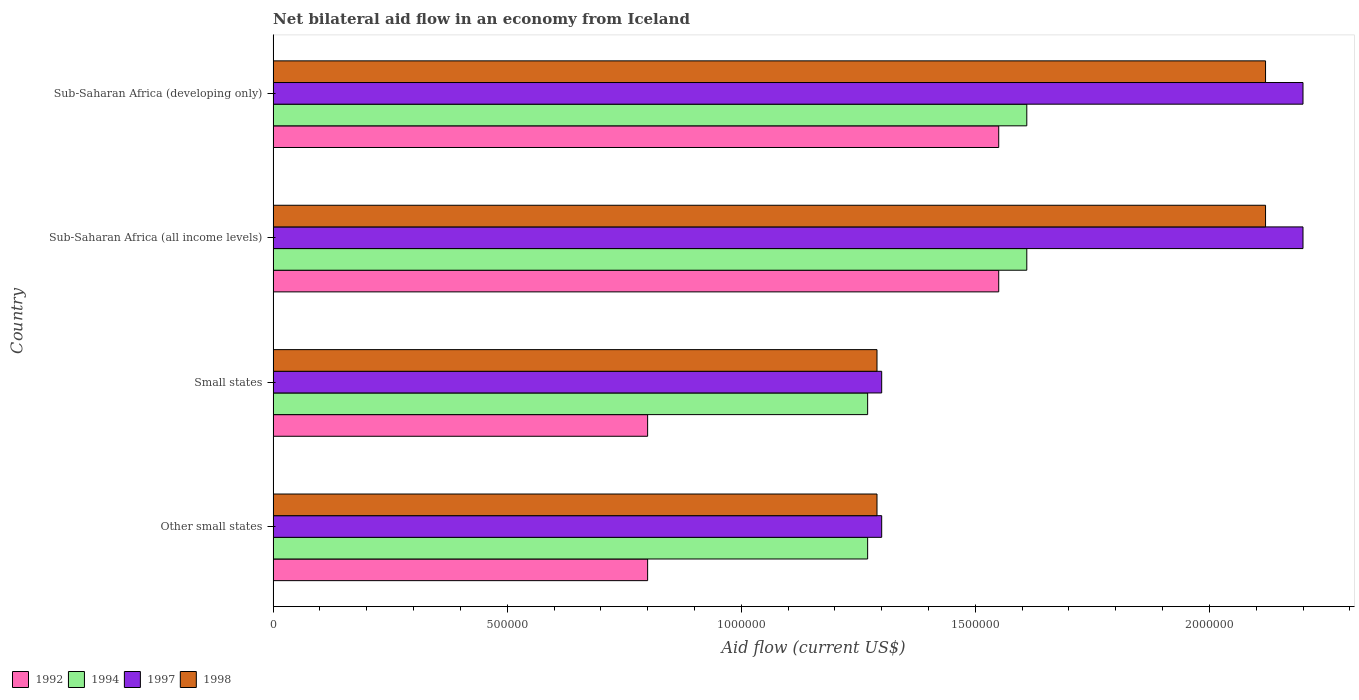How many different coloured bars are there?
Ensure brevity in your answer.  4. Are the number of bars per tick equal to the number of legend labels?
Offer a terse response. Yes. How many bars are there on the 4th tick from the bottom?
Keep it short and to the point. 4. What is the label of the 4th group of bars from the top?
Your response must be concise. Other small states. In how many cases, is the number of bars for a given country not equal to the number of legend labels?
Your answer should be compact. 0. What is the net bilateral aid flow in 1992 in Small states?
Your answer should be very brief. 8.00e+05. Across all countries, what is the maximum net bilateral aid flow in 1994?
Offer a very short reply. 1.61e+06. Across all countries, what is the minimum net bilateral aid flow in 1994?
Your answer should be compact. 1.27e+06. In which country was the net bilateral aid flow in 1998 maximum?
Your answer should be very brief. Sub-Saharan Africa (all income levels). In which country was the net bilateral aid flow in 1997 minimum?
Provide a succinct answer. Other small states. What is the total net bilateral aid flow in 1997 in the graph?
Make the answer very short. 7.00e+06. What is the difference between the net bilateral aid flow in 1992 in Small states and that in Sub-Saharan Africa (developing only)?
Give a very brief answer. -7.50e+05. What is the difference between the net bilateral aid flow in 1994 in Sub-Saharan Africa (developing only) and the net bilateral aid flow in 1992 in Other small states?
Provide a short and direct response. 8.10e+05. What is the average net bilateral aid flow in 1994 per country?
Your answer should be very brief. 1.44e+06. What is the difference between the net bilateral aid flow in 1994 and net bilateral aid flow in 1998 in Sub-Saharan Africa (developing only)?
Provide a succinct answer. -5.10e+05. What is the ratio of the net bilateral aid flow in 1998 in Other small states to that in Sub-Saharan Africa (all income levels)?
Offer a very short reply. 0.61. Is the difference between the net bilateral aid flow in 1994 in Sub-Saharan Africa (all income levels) and Sub-Saharan Africa (developing only) greater than the difference between the net bilateral aid flow in 1998 in Sub-Saharan Africa (all income levels) and Sub-Saharan Africa (developing only)?
Keep it short and to the point. No. In how many countries, is the net bilateral aid flow in 1997 greater than the average net bilateral aid flow in 1997 taken over all countries?
Your answer should be very brief. 2. Is it the case that in every country, the sum of the net bilateral aid flow in 1994 and net bilateral aid flow in 1997 is greater than the sum of net bilateral aid flow in 1992 and net bilateral aid flow in 1998?
Ensure brevity in your answer.  No. What does the 4th bar from the bottom in Sub-Saharan Africa (developing only) represents?
Your response must be concise. 1998. Is it the case that in every country, the sum of the net bilateral aid flow in 1997 and net bilateral aid flow in 1998 is greater than the net bilateral aid flow in 1992?
Your answer should be very brief. Yes. Are all the bars in the graph horizontal?
Your response must be concise. Yes. How many countries are there in the graph?
Offer a terse response. 4. Where does the legend appear in the graph?
Your answer should be very brief. Bottom left. How many legend labels are there?
Your response must be concise. 4. What is the title of the graph?
Your response must be concise. Net bilateral aid flow in an economy from Iceland. What is the label or title of the X-axis?
Your answer should be compact. Aid flow (current US$). What is the label or title of the Y-axis?
Make the answer very short. Country. What is the Aid flow (current US$) in 1994 in Other small states?
Ensure brevity in your answer.  1.27e+06. What is the Aid flow (current US$) in 1997 in Other small states?
Your answer should be compact. 1.30e+06. What is the Aid flow (current US$) in 1998 in Other small states?
Make the answer very short. 1.29e+06. What is the Aid flow (current US$) in 1992 in Small states?
Your answer should be compact. 8.00e+05. What is the Aid flow (current US$) in 1994 in Small states?
Make the answer very short. 1.27e+06. What is the Aid flow (current US$) in 1997 in Small states?
Make the answer very short. 1.30e+06. What is the Aid flow (current US$) of 1998 in Small states?
Your answer should be compact. 1.29e+06. What is the Aid flow (current US$) in 1992 in Sub-Saharan Africa (all income levels)?
Ensure brevity in your answer.  1.55e+06. What is the Aid flow (current US$) of 1994 in Sub-Saharan Africa (all income levels)?
Your answer should be compact. 1.61e+06. What is the Aid flow (current US$) of 1997 in Sub-Saharan Africa (all income levels)?
Provide a short and direct response. 2.20e+06. What is the Aid flow (current US$) of 1998 in Sub-Saharan Africa (all income levels)?
Make the answer very short. 2.12e+06. What is the Aid flow (current US$) of 1992 in Sub-Saharan Africa (developing only)?
Make the answer very short. 1.55e+06. What is the Aid flow (current US$) of 1994 in Sub-Saharan Africa (developing only)?
Your response must be concise. 1.61e+06. What is the Aid flow (current US$) in 1997 in Sub-Saharan Africa (developing only)?
Your response must be concise. 2.20e+06. What is the Aid flow (current US$) in 1998 in Sub-Saharan Africa (developing only)?
Keep it short and to the point. 2.12e+06. Across all countries, what is the maximum Aid flow (current US$) of 1992?
Give a very brief answer. 1.55e+06. Across all countries, what is the maximum Aid flow (current US$) in 1994?
Provide a succinct answer. 1.61e+06. Across all countries, what is the maximum Aid flow (current US$) of 1997?
Provide a succinct answer. 2.20e+06. Across all countries, what is the maximum Aid flow (current US$) of 1998?
Provide a short and direct response. 2.12e+06. Across all countries, what is the minimum Aid flow (current US$) in 1994?
Your answer should be compact. 1.27e+06. Across all countries, what is the minimum Aid flow (current US$) in 1997?
Your answer should be compact. 1.30e+06. Across all countries, what is the minimum Aid flow (current US$) in 1998?
Provide a succinct answer. 1.29e+06. What is the total Aid flow (current US$) of 1992 in the graph?
Your answer should be compact. 4.70e+06. What is the total Aid flow (current US$) in 1994 in the graph?
Ensure brevity in your answer.  5.76e+06. What is the total Aid flow (current US$) in 1997 in the graph?
Offer a terse response. 7.00e+06. What is the total Aid flow (current US$) of 1998 in the graph?
Offer a terse response. 6.82e+06. What is the difference between the Aid flow (current US$) of 1992 in Other small states and that in Small states?
Offer a very short reply. 0. What is the difference between the Aid flow (current US$) of 1994 in Other small states and that in Small states?
Offer a terse response. 0. What is the difference between the Aid flow (current US$) of 1997 in Other small states and that in Small states?
Your response must be concise. 0. What is the difference between the Aid flow (current US$) of 1998 in Other small states and that in Small states?
Keep it short and to the point. 0. What is the difference between the Aid flow (current US$) of 1992 in Other small states and that in Sub-Saharan Africa (all income levels)?
Your response must be concise. -7.50e+05. What is the difference between the Aid flow (current US$) of 1997 in Other small states and that in Sub-Saharan Africa (all income levels)?
Offer a terse response. -9.00e+05. What is the difference between the Aid flow (current US$) in 1998 in Other small states and that in Sub-Saharan Africa (all income levels)?
Offer a terse response. -8.30e+05. What is the difference between the Aid flow (current US$) of 1992 in Other small states and that in Sub-Saharan Africa (developing only)?
Your answer should be compact. -7.50e+05. What is the difference between the Aid flow (current US$) of 1994 in Other small states and that in Sub-Saharan Africa (developing only)?
Provide a short and direct response. -3.40e+05. What is the difference between the Aid flow (current US$) of 1997 in Other small states and that in Sub-Saharan Africa (developing only)?
Give a very brief answer. -9.00e+05. What is the difference between the Aid flow (current US$) of 1998 in Other small states and that in Sub-Saharan Africa (developing only)?
Keep it short and to the point. -8.30e+05. What is the difference between the Aid flow (current US$) in 1992 in Small states and that in Sub-Saharan Africa (all income levels)?
Provide a succinct answer. -7.50e+05. What is the difference between the Aid flow (current US$) of 1997 in Small states and that in Sub-Saharan Africa (all income levels)?
Your response must be concise. -9.00e+05. What is the difference between the Aid flow (current US$) of 1998 in Small states and that in Sub-Saharan Africa (all income levels)?
Offer a terse response. -8.30e+05. What is the difference between the Aid flow (current US$) in 1992 in Small states and that in Sub-Saharan Africa (developing only)?
Your answer should be very brief. -7.50e+05. What is the difference between the Aid flow (current US$) of 1994 in Small states and that in Sub-Saharan Africa (developing only)?
Keep it short and to the point. -3.40e+05. What is the difference between the Aid flow (current US$) of 1997 in Small states and that in Sub-Saharan Africa (developing only)?
Keep it short and to the point. -9.00e+05. What is the difference between the Aid flow (current US$) in 1998 in Small states and that in Sub-Saharan Africa (developing only)?
Offer a terse response. -8.30e+05. What is the difference between the Aid flow (current US$) of 1992 in Other small states and the Aid flow (current US$) of 1994 in Small states?
Give a very brief answer. -4.70e+05. What is the difference between the Aid flow (current US$) of 1992 in Other small states and the Aid flow (current US$) of 1997 in Small states?
Provide a short and direct response. -5.00e+05. What is the difference between the Aid flow (current US$) in 1992 in Other small states and the Aid flow (current US$) in 1998 in Small states?
Your answer should be compact. -4.90e+05. What is the difference between the Aid flow (current US$) in 1994 in Other small states and the Aid flow (current US$) in 1998 in Small states?
Give a very brief answer. -2.00e+04. What is the difference between the Aid flow (current US$) in 1992 in Other small states and the Aid flow (current US$) in 1994 in Sub-Saharan Africa (all income levels)?
Keep it short and to the point. -8.10e+05. What is the difference between the Aid flow (current US$) in 1992 in Other small states and the Aid flow (current US$) in 1997 in Sub-Saharan Africa (all income levels)?
Provide a short and direct response. -1.40e+06. What is the difference between the Aid flow (current US$) of 1992 in Other small states and the Aid flow (current US$) of 1998 in Sub-Saharan Africa (all income levels)?
Your answer should be very brief. -1.32e+06. What is the difference between the Aid flow (current US$) of 1994 in Other small states and the Aid flow (current US$) of 1997 in Sub-Saharan Africa (all income levels)?
Your answer should be very brief. -9.30e+05. What is the difference between the Aid flow (current US$) in 1994 in Other small states and the Aid flow (current US$) in 1998 in Sub-Saharan Africa (all income levels)?
Your answer should be compact. -8.50e+05. What is the difference between the Aid flow (current US$) in 1997 in Other small states and the Aid flow (current US$) in 1998 in Sub-Saharan Africa (all income levels)?
Offer a very short reply. -8.20e+05. What is the difference between the Aid flow (current US$) in 1992 in Other small states and the Aid flow (current US$) in 1994 in Sub-Saharan Africa (developing only)?
Provide a short and direct response. -8.10e+05. What is the difference between the Aid flow (current US$) in 1992 in Other small states and the Aid flow (current US$) in 1997 in Sub-Saharan Africa (developing only)?
Your answer should be compact. -1.40e+06. What is the difference between the Aid flow (current US$) in 1992 in Other small states and the Aid flow (current US$) in 1998 in Sub-Saharan Africa (developing only)?
Keep it short and to the point. -1.32e+06. What is the difference between the Aid flow (current US$) of 1994 in Other small states and the Aid flow (current US$) of 1997 in Sub-Saharan Africa (developing only)?
Ensure brevity in your answer.  -9.30e+05. What is the difference between the Aid flow (current US$) in 1994 in Other small states and the Aid flow (current US$) in 1998 in Sub-Saharan Africa (developing only)?
Provide a succinct answer. -8.50e+05. What is the difference between the Aid flow (current US$) in 1997 in Other small states and the Aid flow (current US$) in 1998 in Sub-Saharan Africa (developing only)?
Ensure brevity in your answer.  -8.20e+05. What is the difference between the Aid flow (current US$) of 1992 in Small states and the Aid flow (current US$) of 1994 in Sub-Saharan Africa (all income levels)?
Give a very brief answer. -8.10e+05. What is the difference between the Aid flow (current US$) in 1992 in Small states and the Aid flow (current US$) in 1997 in Sub-Saharan Africa (all income levels)?
Your response must be concise. -1.40e+06. What is the difference between the Aid flow (current US$) of 1992 in Small states and the Aid flow (current US$) of 1998 in Sub-Saharan Africa (all income levels)?
Provide a short and direct response. -1.32e+06. What is the difference between the Aid flow (current US$) in 1994 in Small states and the Aid flow (current US$) in 1997 in Sub-Saharan Africa (all income levels)?
Ensure brevity in your answer.  -9.30e+05. What is the difference between the Aid flow (current US$) of 1994 in Small states and the Aid flow (current US$) of 1998 in Sub-Saharan Africa (all income levels)?
Your response must be concise. -8.50e+05. What is the difference between the Aid flow (current US$) in 1997 in Small states and the Aid flow (current US$) in 1998 in Sub-Saharan Africa (all income levels)?
Give a very brief answer. -8.20e+05. What is the difference between the Aid flow (current US$) in 1992 in Small states and the Aid flow (current US$) in 1994 in Sub-Saharan Africa (developing only)?
Your response must be concise. -8.10e+05. What is the difference between the Aid flow (current US$) of 1992 in Small states and the Aid flow (current US$) of 1997 in Sub-Saharan Africa (developing only)?
Provide a short and direct response. -1.40e+06. What is the difference between the Aid flow (current US$) in 1992 in Small states and the Aid flow (current US$) in 1998 in Sub-Saharan Africa (developing only)?
Offer a terse response. -1.32e+06. What is the difference between the Aid flow (current US$) of 1994 in Small states and the Aid flow (current US$) of 1997 in Sub-Saharan Africa (developing only)?
Give a very brief answer. -9.30e+05. What is the difference between the Aid flow (current US$) of 1994 in Small states and the Aid flow (current US$) of 1998 in Sub-Saharan Africa (developing only)?
Make the answer very short. -8.50e+05. What is the difference between the Aid flow (current US$) of 1997 in Small states and the Aid flow (current US$) of 1998 in Sub-Saharan Africa (developing only)?
Your response must be concise. -8.20e+05. What is the difference between the Aid flow (current US$) of 1992 in Sub-Saharan Africa (all income levels) and the Aid flow (current US$) of 1994 in Sub-Saharan Africa (developing only)?
Provide a succinct answer. -6.00e+04. What is the difference between the Aid flow (current US$) in 1992 in Sub-Saharan Africa (all income levels) and the Aid flow (current US$) in 1997 in Sub-Saharan Africa (developing only)?
Give a very brief answer. -6.50e+05. What is the difference between the Aid flow (current US$) of 1992 in Sub-Saharan Africa (all income levels) and the Aid flow (current US$) of 1998 in Sub-Saharan Africa (developing only)?
Provide a succinct answer. -5.70e+05. What is the difference between the Aid flow (current US$) of 1994 in Sub-Saharan Africa (all income levels) and the Aid flow (current US$) of 1997 in Sub-Saharan Africa (developing only)?
Your answer should be very brief. -5.90e+05. What is the difference between the Aid flow (current US$) in 1994 in Sub-Saharan Africa (all income levels) and the Aid flow (current US$) in 1998 in Sub-Saharan Africa (developing only)?
Keep it short and to the point. -5.10e+05. What is the average Aid flow (current US$) of 1992 per country?
Your response must be concise. 1.18e+06. What is the average Aid flow (current US$) in 1994 per country?
Offer a very short reply. 1.44e+06. What is the average Aid flow (current US$) in 1997 per country?
Offer a very short reply. 1.75e+06. What is the average Aid flow (current US$) of 1998 per country?
Offer a very short reply. 1.70e+06. What is the difference between the Aid flow (current US$) in 1992 and Aid flow (current US$) in 1994 in Other small states?
Your answer should be compact. -4.70e+05. What is the difference between the Aid flow (current US$) in 1992 and Aid flow (current US$) in 1997 in Other small states?
Your response must be concise. -5.00e+05. What is the difference between the Aid flow (current US$) of 1992 and Aid flow (current US$) of 1998 in Other small states?
Your answer should be compact. -4.90e+05. What is the difference between the Aid flow (current US$) of 1994 and Aid flow (current US$) of 1997 in Other small states?
Make the answer very short. -3.00e+04. What is the difference between the Aid flow (current US$) of 1992 and Aid flow (current US$) of 1994 in Small states?
Your answer should be very brief. -4.70e+05. What is the difference between the Aid flow (current US$) in 1992 and Aid flow (current US$) in 1997 in Small states?
Offer a very short reply. -5.00e+05. What is the difference between the Aid flow (current US$) of 1992 and Aid flow (current US$) of 1998 in Small states?
Keep it short and to the point. -4.90e+05. What is the difference between the Aid flow (current US$) in 1994 and Aid flow (current US$) in 1997 in Small states?
Give a very brief answer. -3.00e+04. What is the difference between the Aid flow (current US$) in 1992 and Aid flow (current US$) in 1997 in Sub-Saharan Africa (all income levels)?
Offer a terse response. -6.50e+05. What is the difference between the Aid flow (current US$) of 1992 and Aid flow (current US$) of 1998 in Sub-Saharan Africa (all income levels)?
Your answer should be very brief. -5.70e+05. What is the difference between the Aid flow (current US$) in 1994 and Aid flow (current US$) in 1997 in Sub-Saharan Africa (all income levels)?
Your answer should be very brief. -5.90e+05. What is the difference between the Aid flow (current US$) in 1994 and Aid flow (current US$) in 1998 in Sub-Saharan Africa (all income levels)?
Offer a terse response. -5.10e+05. What is the difference between the Aid flow (current US$) in 1997 and Aid flow (current US$) in 1998 in Sub-Saharan Africa (all income levels)?
Provide a short and direct response. 8.00e+04. What is the difference between the Aid flow (current US$) in 1992 and Aid flow (current US$) in 1997 in Sub-Saharan Africa (developing only)?
Give a very brief answer. -6.50e+05. What is the difference between the Aid flow (current US$) of 1992 and Aid flow (current US$) of 1998 in Sub-Saharan Africa (developing only)?
Keep it short and to the point. -5.70e+05. What is the difference between the Aid flow (current US$) of 1994 and Aid flow (current US$) of 1997 in Sub-Saharan Africa (developing only)?
Offer a very short reply. -5.90e+05. What is the difference between the Aid flow (current US$) in 1994 and Aid flow (current US$) in 1998 in Sub-Saharan Africa (developing only)?
Provide a short and direct response. -5.10e+05. What is the ratio of the Aid flow (current US$) of 1992 in Other small states to that in Small states?
Offer a terse response. 1. What is the ratio of the Aid flow (current US$) of 1994 in Other small states to that in Small states?
Keep it short and to the point. 1. What is the ratio of the Aid flow (current US$) of 1992 in Other small states to that in Sub-Saharan Africa (all income levels)?
Give a very brief answer. 0.52. What is the ratio of the Aid flow (current US$) in 1994 in Other small states to that in Sub-Saharan Africa (all income levels)?
Keep it short and to the point. 0.79. What is the ratio of the Aid flow (current US$) in 1997 in Other small states to that in Sub-Saharan Africa (all income levels)?
Ensure brevity in your answer.  0.59. What is the ratio of the Aid flow (current US$) of 1998 in Other small states to that in Sub-Saharan Africa (all income levels)?
Ensure brevity in your answer.  0.61. What is the ratio of the Aid flow (current US$) in 1992 in Other small states to that in Sub-Saharan Africa (developing only)?
Give a very brief answer. 0.52. What is the ratio of the Aid flow (current US$) in 1994 in Other small states to that in Sub-Saharan Africa (developing only)?
Offer a very short reply. 0.79. What is the ratio of the Aid flow (current US$) of 1997 in Other small states to that in Sub-Saharan Africa (developing only)?
Your answer should be very brief. 0.59. What is the ratio of the Aid flow (current US$) in 1998 in Other small states to that in Sub-Saharan Africa (developing only)?
Your response must be concise. 0.61. What is the ratio of the Aid flow (current US$) of 1992 in Small states to that in Sub-Saharan Africa (all income levels)?
Provide a short and direct response. 0.52. What is the ratio of the Aid flow (current US$) in 1994 in Small states to that in Sub-Saharan Africa (all income levels)?
Keep it short and to the point. 0.79. What is the ratio of the Aid flow (current US$) of 1997 in Small states to that in Sub-Saharan Africa (all income levels)?
Your answer should be compact. 0.59. What is the ratio of the Aid flow (current US$) of 1998 in Small states to that in Sub-Saharan Africa (all income levels)?
Your answer should be compact. 0.61. What is the ratio of the Aid flow (current US$) of 1992 in Small states to that in Sub-Saharan Africa (developing only)?
Make the answer very short. 0.52. What is the ratio of the Aid flow (current US$) in 1994 in Small states to that in Sub-Saharan Africa (developing only)?
Ensure brevity in your answer.  0.79. What is the ratio of the Aid flow (current US$) in 1997 in Small states to that in Sub-Saharan Africa (developing only)?
Your response must be concise. 0.59. What is the ratio of the Aid flow (current US$) of 1998 in Small states to that in Sub-Saharan Africa (developing only)?
Your answer should be very brief. 0.61. What is the ratio of the Aid flow (current US$) in 1992 in Sub-Saharan Africa (all income levels) to that in Sub-Saharan Africa (developing only)?
Offer a very short reply. 1. What is the ratio of the Aid flow (current US$) of 1997 in Sub-Saharan Africa (all income levels) to that in Sub-Saharan Africa (developing only)?
Make the answer very short. 1. What is the difference between the highest and the second highest Aid flow (current US$) of 1994?
Ensure brevity in your answer.  0. What is the difference between the highest and the second highest Aid flow (current US$) of 1997?
Your answer should be very brief. 0. What is the difference between the highest and the lowest Aid flow (current US$) of 1992?
Offer a very short reply. 7.50e+05. What is the difference between the highest and the lowest Aid flow (current US$) in 1997?
Your response must be concise. 9.00e+05. What is the difference between the highest and the lowest Aid flow (current US$) of 1998?
Provide a short and direct response. 8.30e+05. 